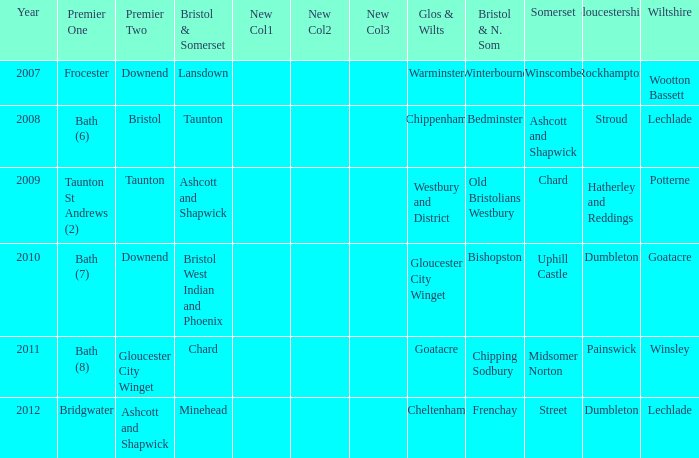Who many times is gloucestershire is painswick? 1.0. 